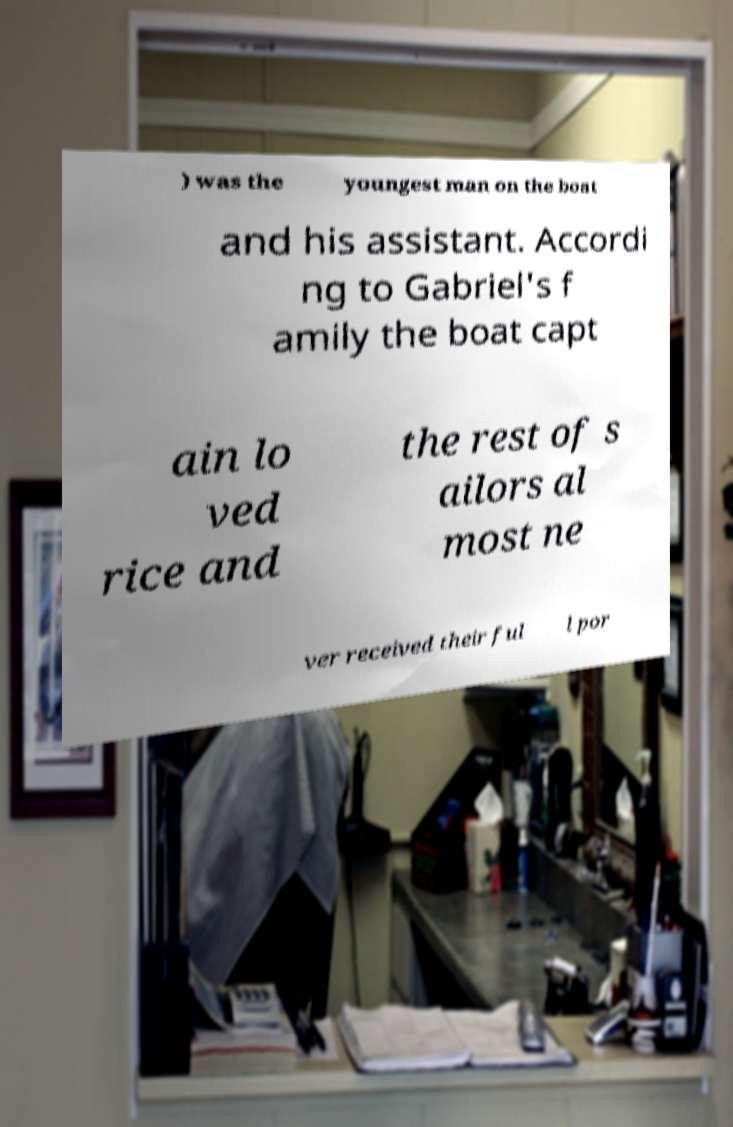Please identify and transcribe the text found in this image. ) was the youngest man on the boat and his assistant. Accordi ng to Gabriel's f amily the boat capt ain lo ved rice and the rest of s ailors al most ne ver received their ful l por 